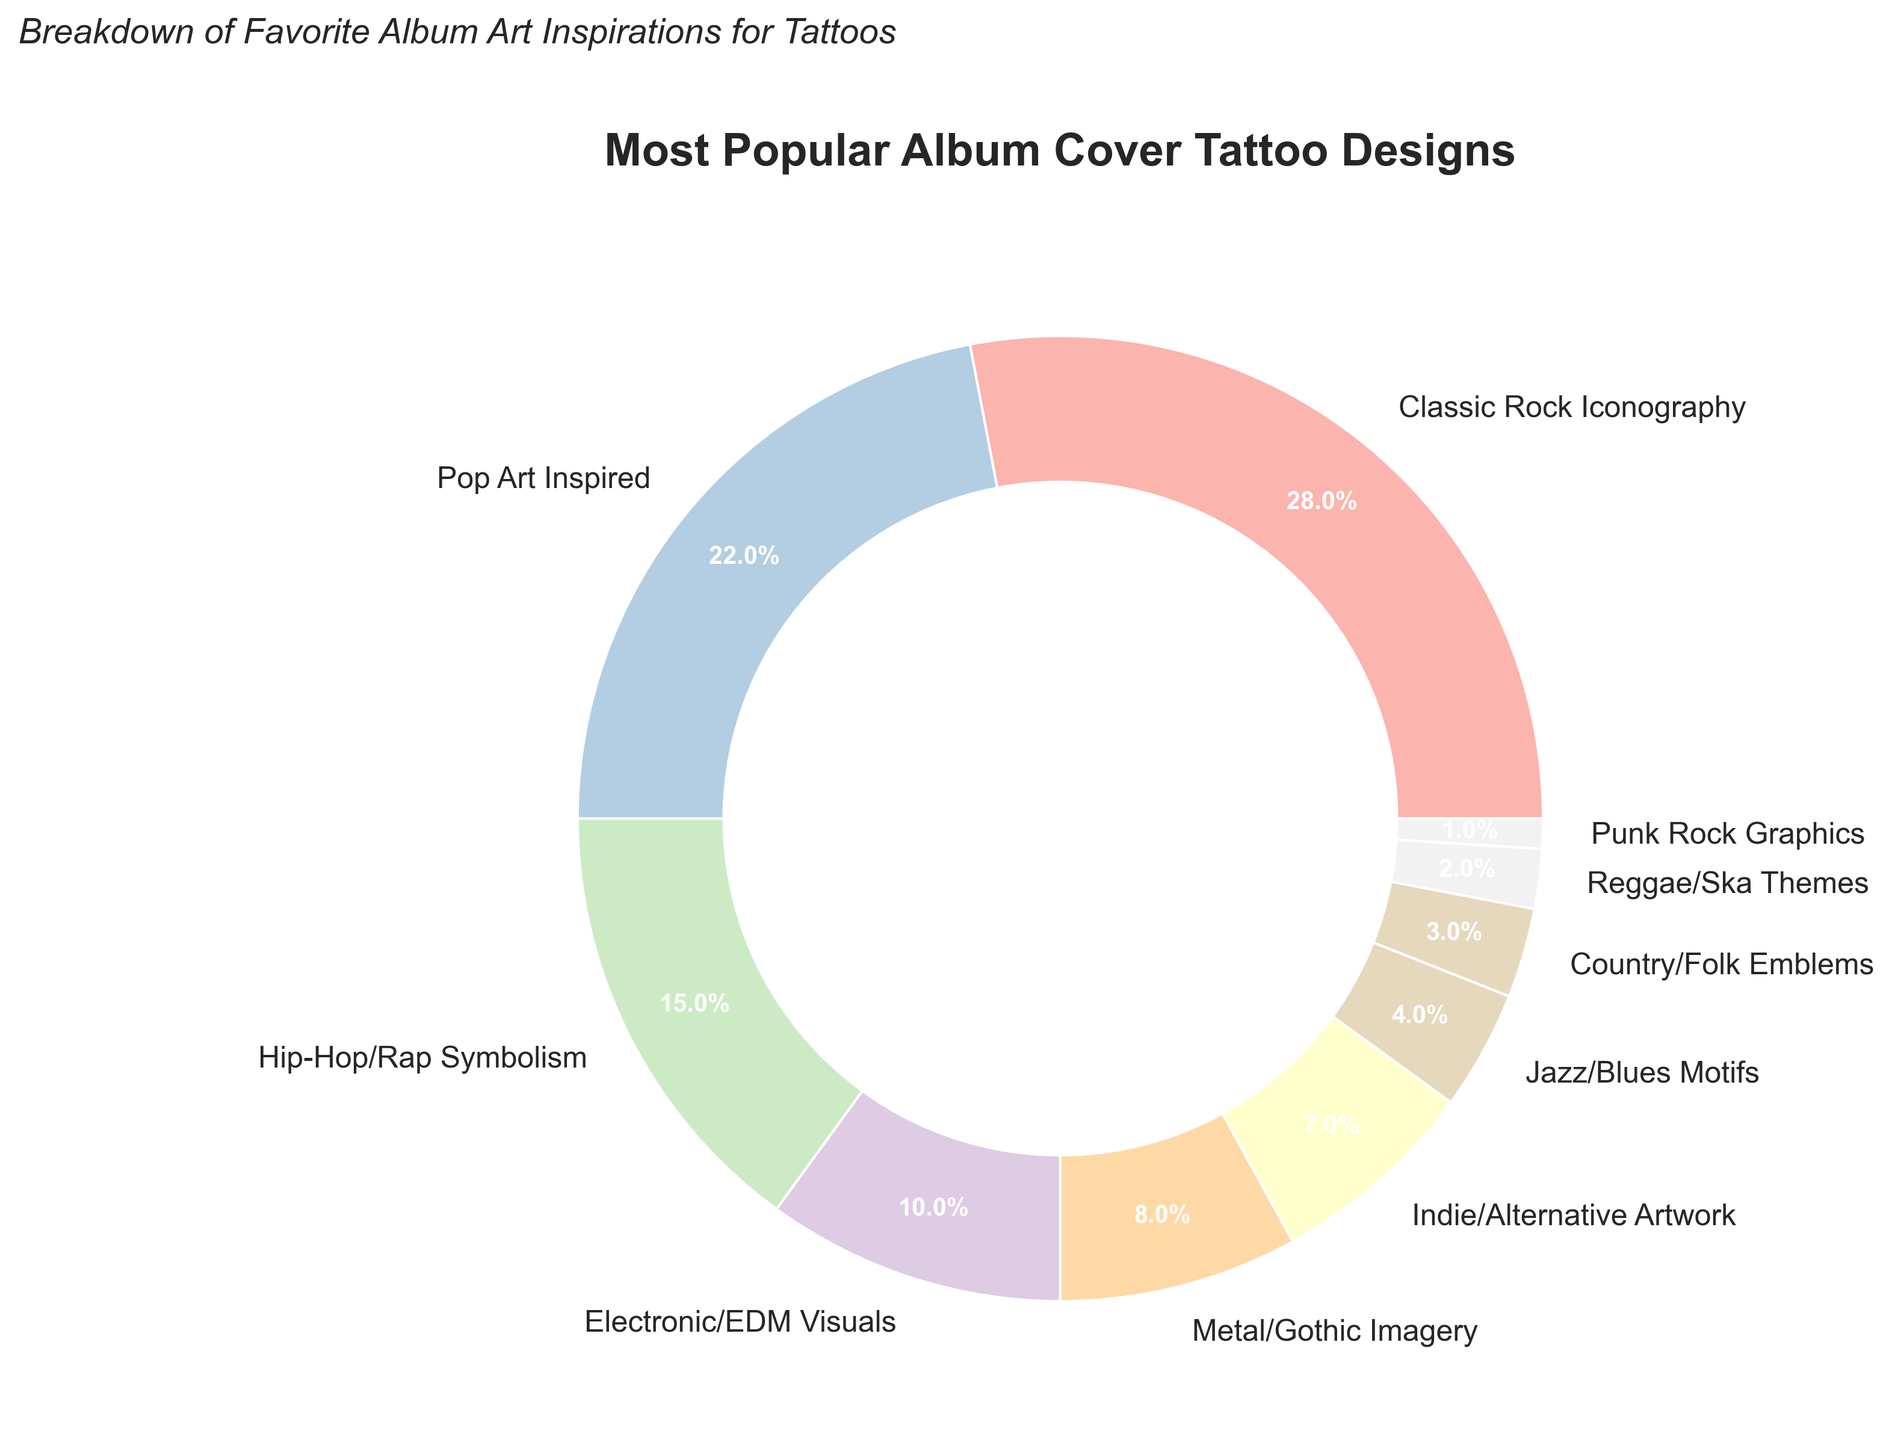Which album cover design is the most popular? The largest section of the pie chart represents Classic Rock Iconography, indicating it has the highest percentage.
Answer: Classic Rock Iconography What is the total percentage of tattoos inspired by genres other than Rock? Sum the percentages of all other categories: Pop Art Inspired (22%) + Hip-Hop/Rap Symbolism (15%) + Electronic/EDM Visuals (10%) + Metal/Gothic Imagery (8%) + Indie/Alternative Artwork (7%) + Jazz/Blues Motifs (4%) + Country/Folk Emblems (3%) + Reggae/Ska Themes (2%) + Punk Rock Graphics (1%). This equals 72%.
Answer: 72% Is Pop Art Inspired more popular than Hip-Hop/Rap Symbolism as a tattoo design? Compare the percentages from the chart: Pop Art Inspired (22%) and Hip-Hop/Rap Symbolism (15%). Since 22% is greater than 15%, Pop Art Inspired is more popular.
Answer: Yes What is the difference in popularity between Classic Rock Iconography and Indie/Alternative Artwork? Subtract the percentage of Indie/Alternative Artwork (7%) from Classic Rock Iconography (28%): 28% - 7% = 21%.
Answer: 21% Which genre has the smallest share of tattoo designs? The smallest section of the pie chart represents Punk Rock Graphics, indicating it has the lowest percentage.
Answer: Punk Rock Graphics How much more popular is Electronic/EDM Visuals compared to Country/Folk Emblems? Subtract the percentage of Country/Folk Emblems (3%) from Electronic/EDM Visuals (10%): 10% - 3% = 7%.
Answer: 7% What combined percentage do the top three most popular designs (Classic Rock Iconography, Pop Art Inspired, and Hip-Hop/Rap Symbolism) represent? Add the percentages of Classic Rock Iconography (28%), Pop Art Inspired (22%), and Hip-Hop/Rap Symbolism (15%): 28% + 22% + 15% = 65%.
Answer: 65% If you combine the percentages of Jazz/Blues Motifs and Reggae/Ska Themes, does their total equal more than that of Electronic/EDM Visuals? Add the percentages of Jazz/Blues Motifs (4%) and Reggae/Ska Themes (2%): 4% + 2% = 6%. Compare this to Electronic/EDM Visuals (10%), since 6% is less than 10%, their total is not more.
Answer: No Which category is exactly twice as popular as another genre? Compare the percentages to find a category that is exactly double another: Electronic/EDM Visuals (10%) is twice as popular as Jazz/Blues Motifs (4% + 2% = 6%), Metal/Gothic Imagery (8%) is twice as popular as Country/Folk Emblems (3%).
Answer: Electronic/EDM Visuals and Metal/Gothic Imagery What is the median percentage value of the album cover designs? Arrange the percentages in ascending order: (1, 2, 3, 4, 7, 8, 10, 15, 22, 28). With an even number of data points, the median is the average of the 5th and 6th values: (7 + 8) / 2 = 7.5%.
Answer: 7.5% 